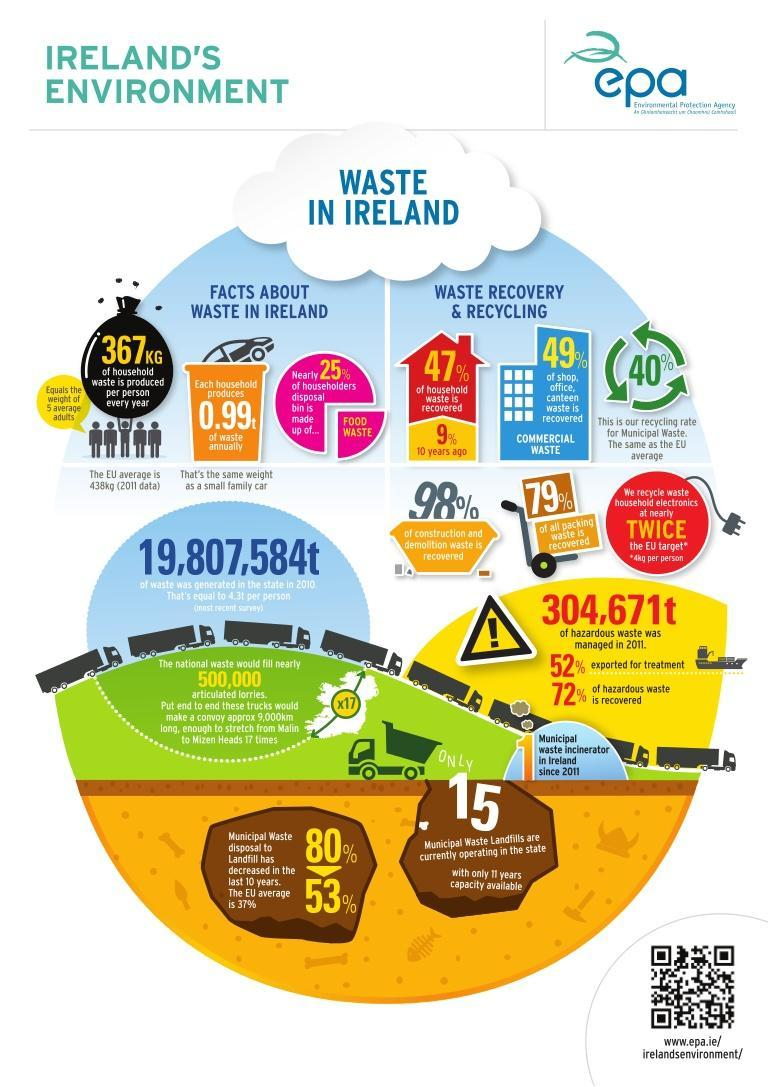What is the recovery percentage of construction and demolition waste?
Answer the question with a short phrase. 98% What is the current percent of municipal waste disposal to landfill? 53% What is recovered at a rate of 79%? packing waste What makes up a quarter of the household waste? food waste What is the commercial waste recovery percentage? 49% What was the percent of household waste recovery a decade ago? 9% What is the current recovery percentage of household waste? 47% 